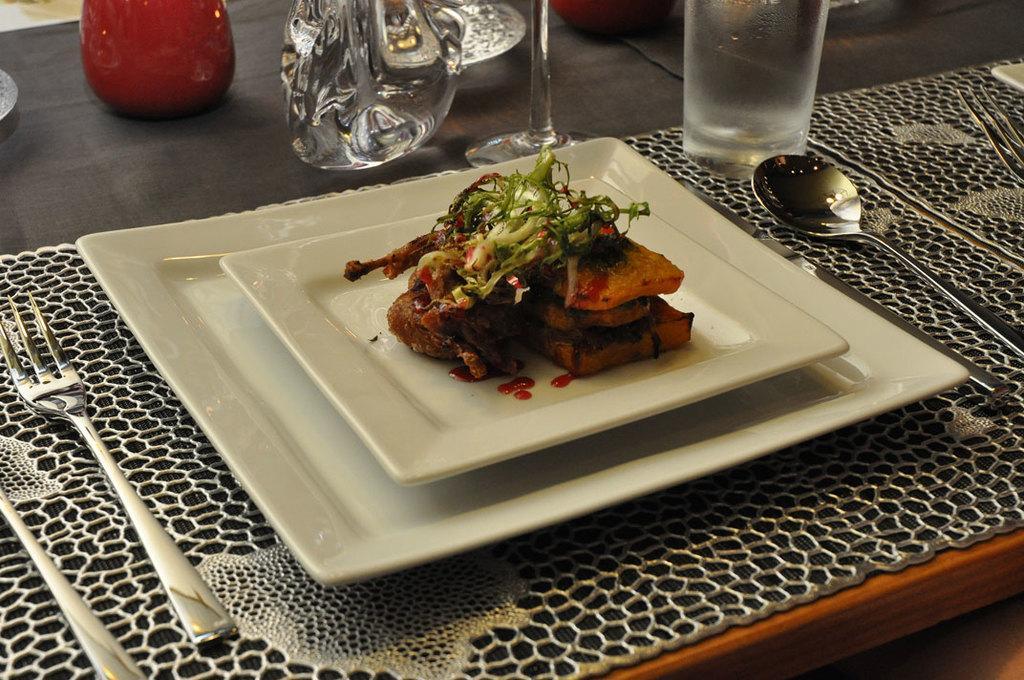Can you describe this image briefly? At the bottom of the image there is a table, on the table there is a plate. In the plate there is food. Surrounding the plate we can see some spoons, forks and glasses. 